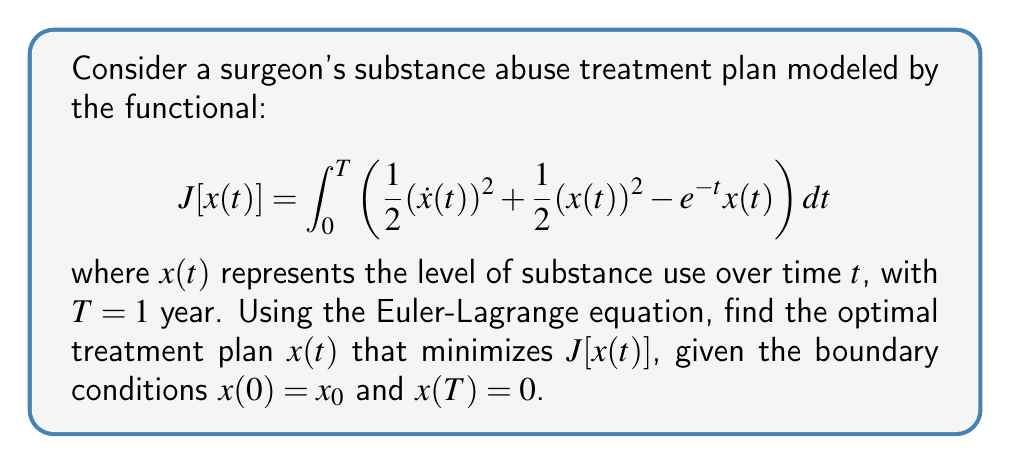Help me with this question. 1) The Euler-Lagrange equation for this variational problem is:

   $$\frac{\partial F}{\partial x} - \frac{d}{dt}\left(\frac{\partial F}{\partial \dot{x}}\right) = 0$$

   where $F = \frac{1}{2}(\dot{x}(t))^2 + \frac{1}{2}(x(t))^2 - e^{-t}x(t)$

2) Calculate the partial derivatives:
   
   $$\frac{\partial F}{\partial x} = x(t) - e^{-t}$$
   $$\frac{\partial F}{\partial \dot{x}} = \dot{x}(t)$$

3) Substitute into the Euler-Lagrange equation:

   $$x(t) - e^{-t} - \frac{d}{dt}(\dot{x}(t)) = 0$$

4) Simplify:

   $$x(t) - e^{-t} - \ddot{x}(t) = 0$$

5) Rearrange to get the differential equation:

   $$\ddot{x}(t) - x(t) = -e^{-t}$$

6) The general solution to this differential equation is:

   $$x(t) = A e^t + B e^{-t} + \frac{1}{2}te^{-t}$$

   where $A$ and $B$ are constants to be determined by the boundary conditions.

7) Apply the boundary conditions:
   
   At $t=0$: $x(0) = x_0 = A + B$
   At $t=T=1$: $x(1) = 0 = Ae + Be^{-1} + \frac{1}{2}e^{-1}$

8) Solve this system of equations for $A$ and $B$:

   $$A = \frac{x_0e - \frac{1}{2}}{e^2 - 1}, \quad B = \frac{ex_0 + \frac{1}{2}}{1 - e^2}$$

9) The optimal treatment plan is therefore:

   $$x(t) = \frac{x_0e - \frac{1}{2}}{e^2 - 1}e^t + \frac{ex_0 + \frac{1}{2}}{1 - e^2}e^{-t} + \frac{1}{2}te^{-t}$$
Answer: $x(t) = \frac{x_0e - \frac{1}{2}}{e^2 - 1}e^t + \frac{ex_0 + \frac{1}{2}}{1 - e^2}e^{-t} + \frac{1}{2}te^{-t}$ 